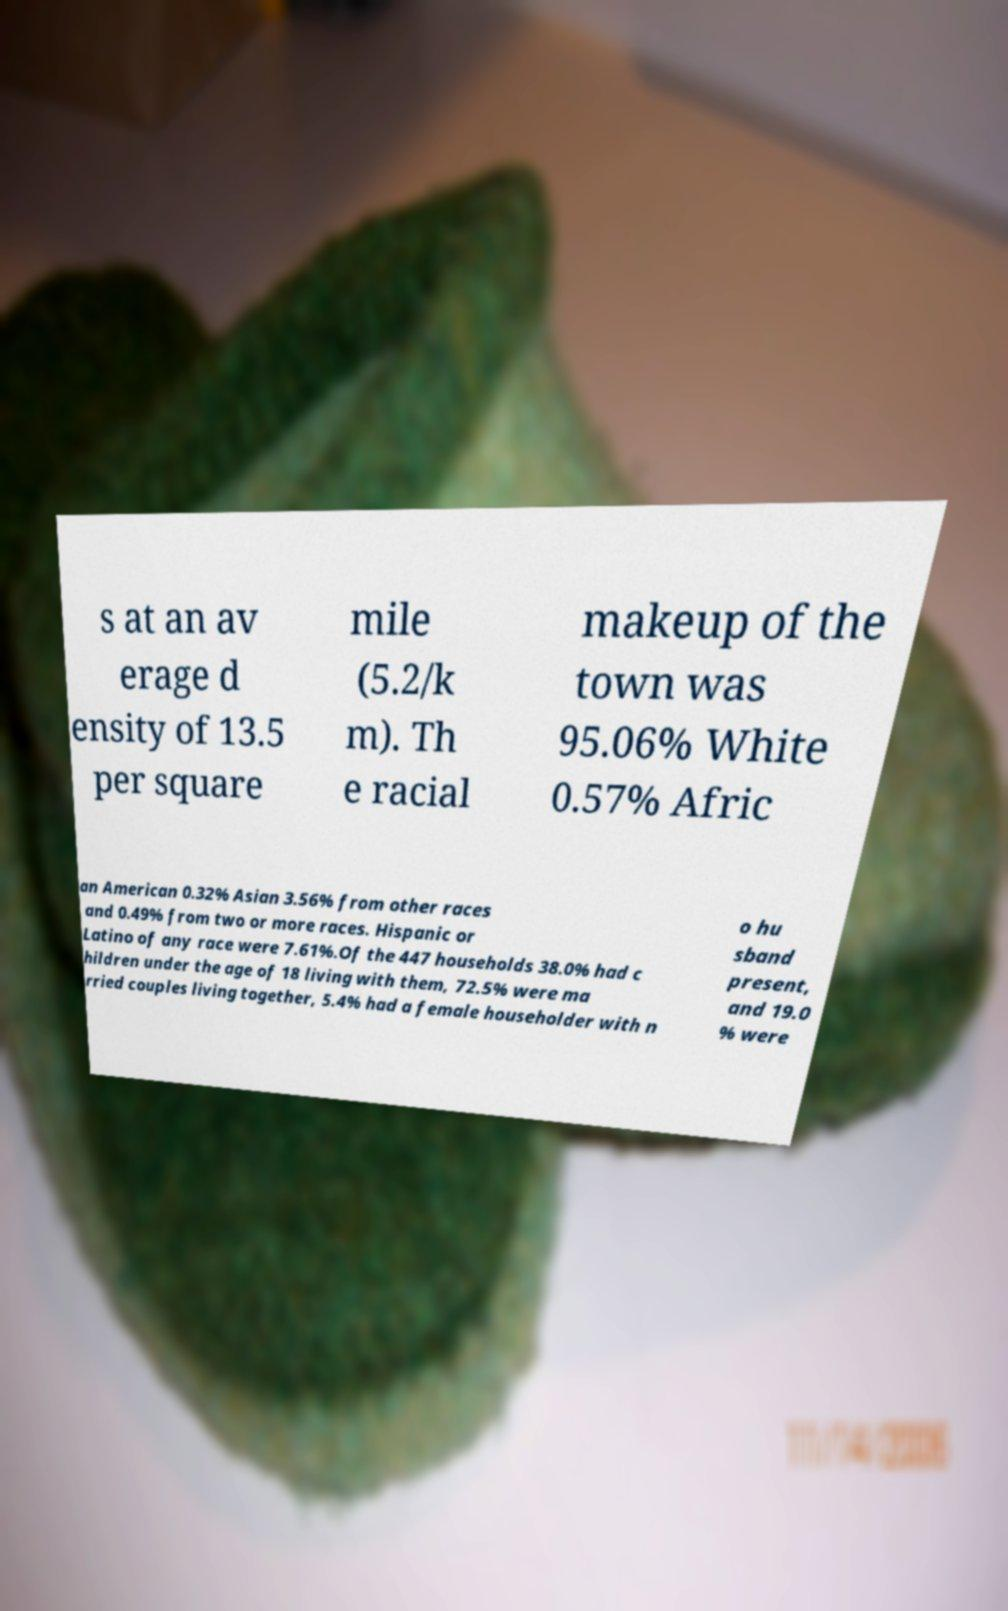There's text embedded in this image that I need extracted. Can you transcribe it verbatim? s at an av erage d ensity of 13.5 per square mile (5.2/k m). Th e racial makeup of the town was 95.06% White 0.57% Afric an American 0.32% Asian 3.56% from other races and 0.49% from two or more races. Hispanic or Latino of any race were 7.61%.Of the 447 households 38.0% had c hildren under the age of 18 living with them, 72.5% were ma rried couples living together, 5.4% had a female householder with n o hu sband present, and 19.0 % were 